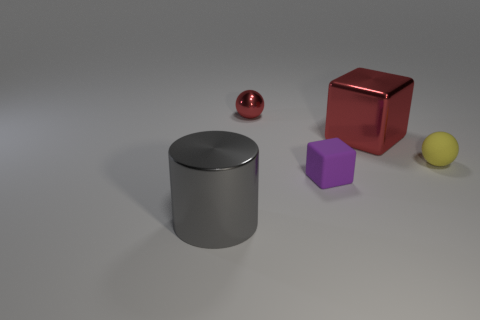Add 1 small shiny balls. How many objects exist? 6 Subtract all spheres. How many objects are left? 3 Add 5 brown objects. How many brown objects exist? 5 Subtract 0 purple balls. How many objects are left? 5 Subtract all spheres. Subtract all tiny matte objects. How many objects are left? 1 Add 1 red metallic cubes. How many red metallic cubes are left? 2 